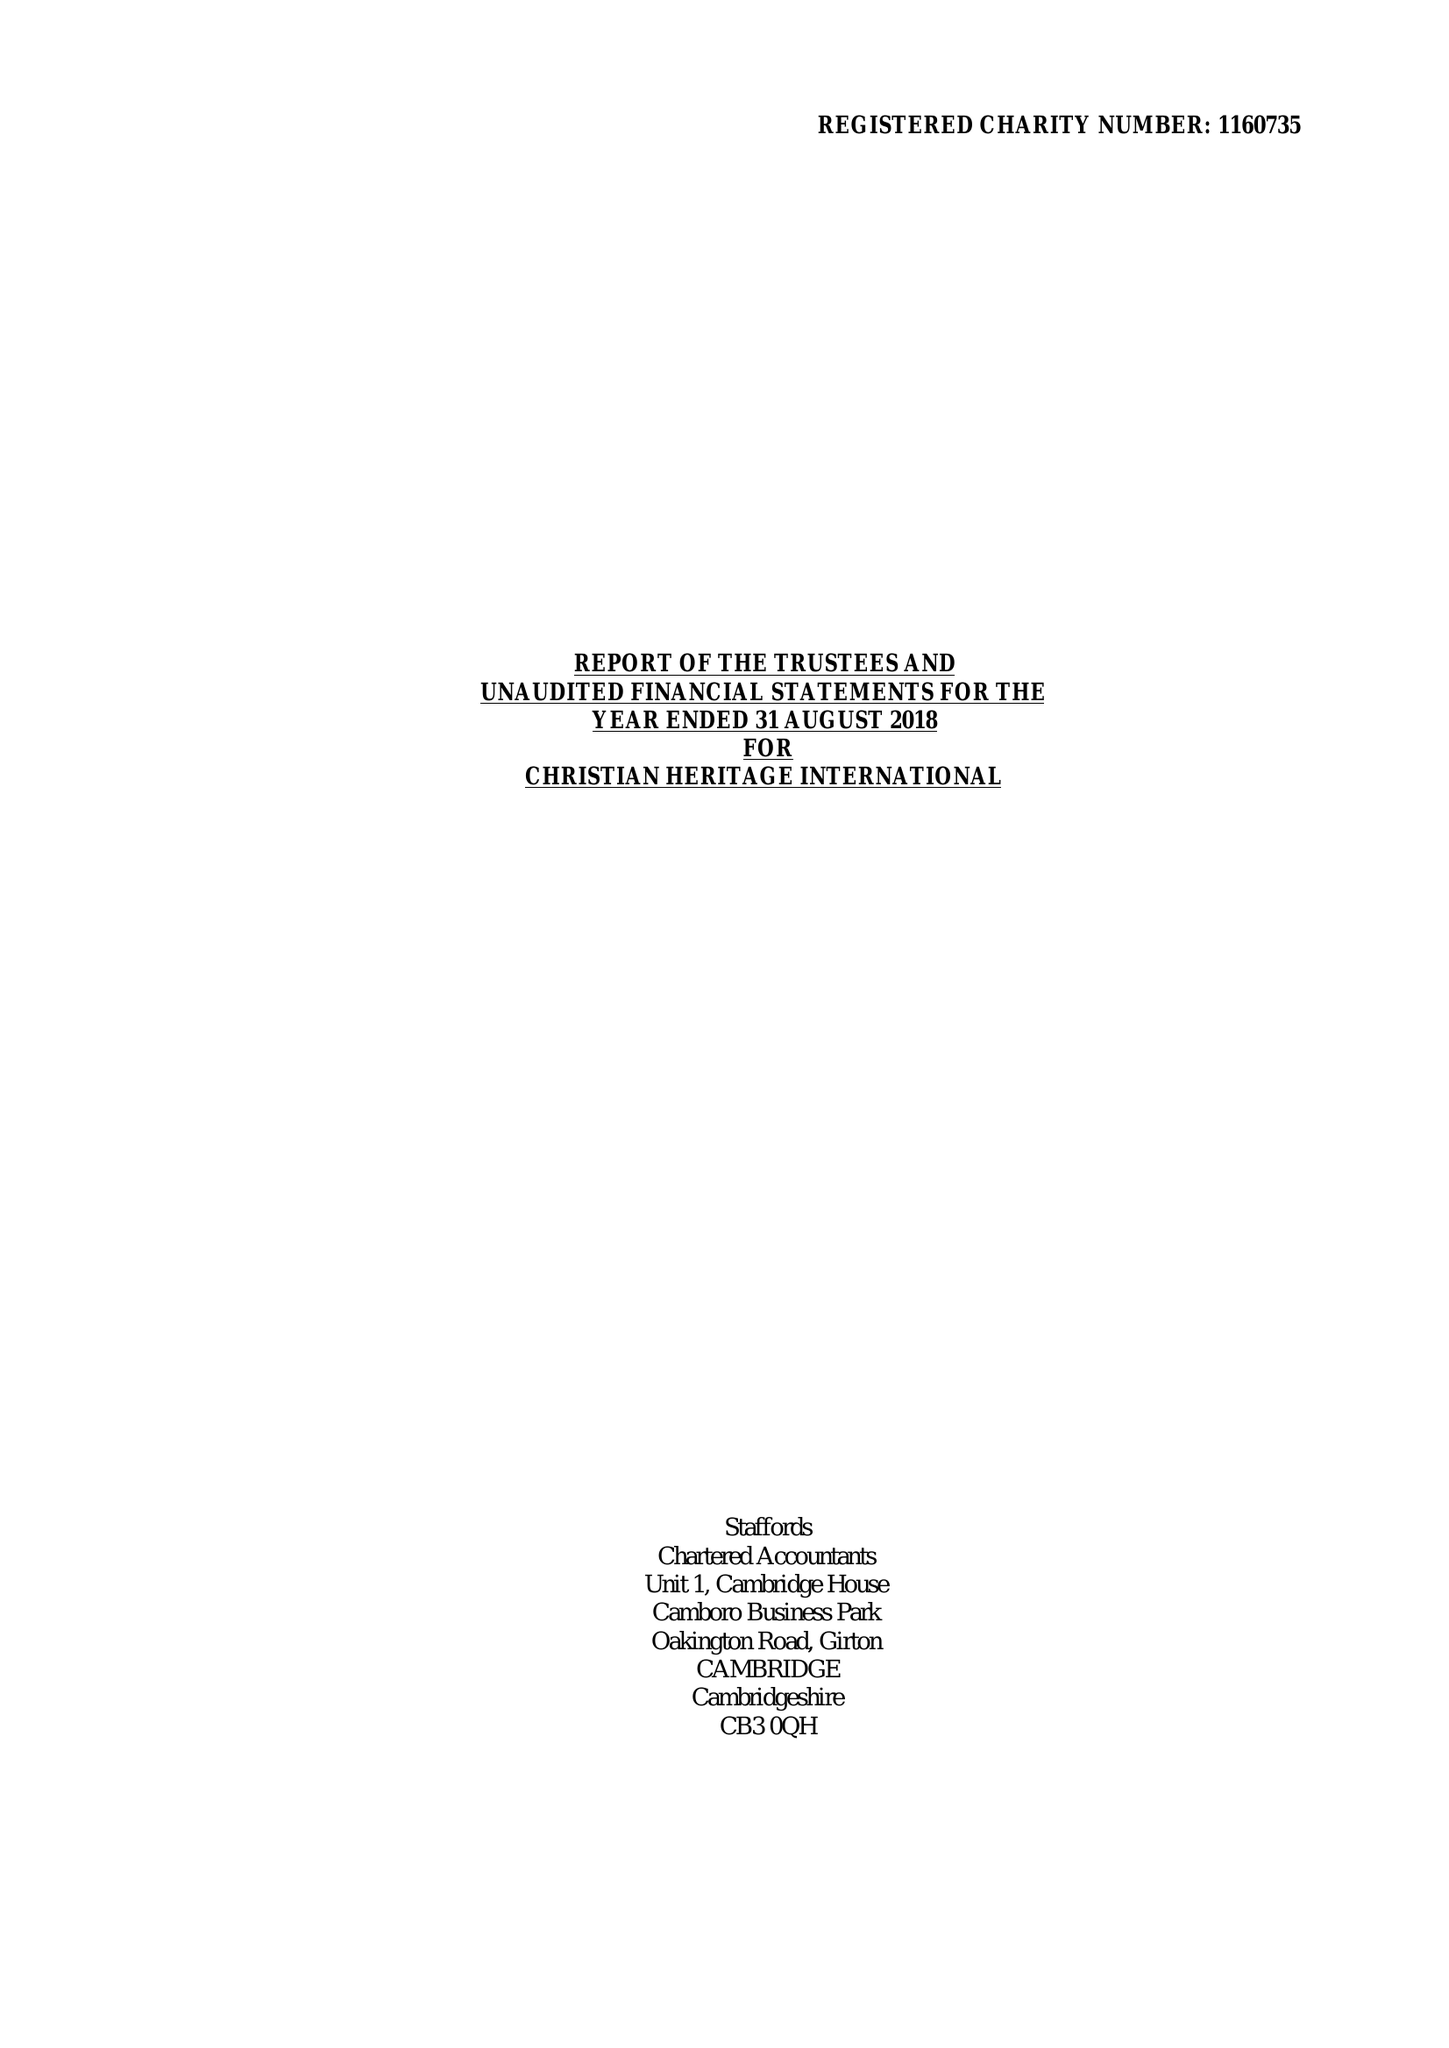What is the value for the charity_number?
Answer the question using a single word or phrase. 1160735 